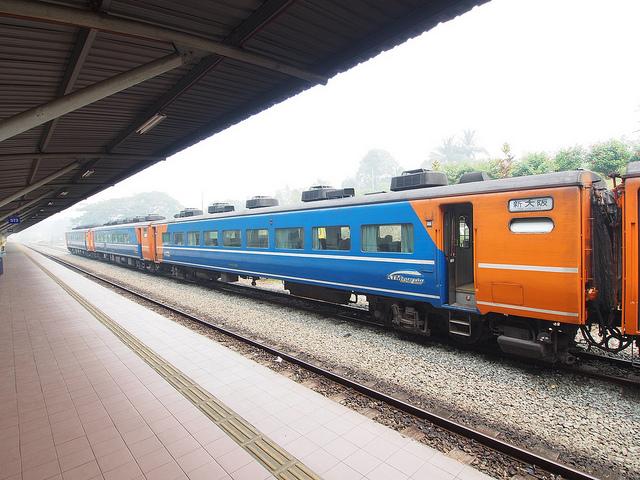Is this train in transit?
Give a very brief answer. Yes. Is the train green?
Write a very short answer. No. How many tracks are there?
Give a very brief answer. 2. 